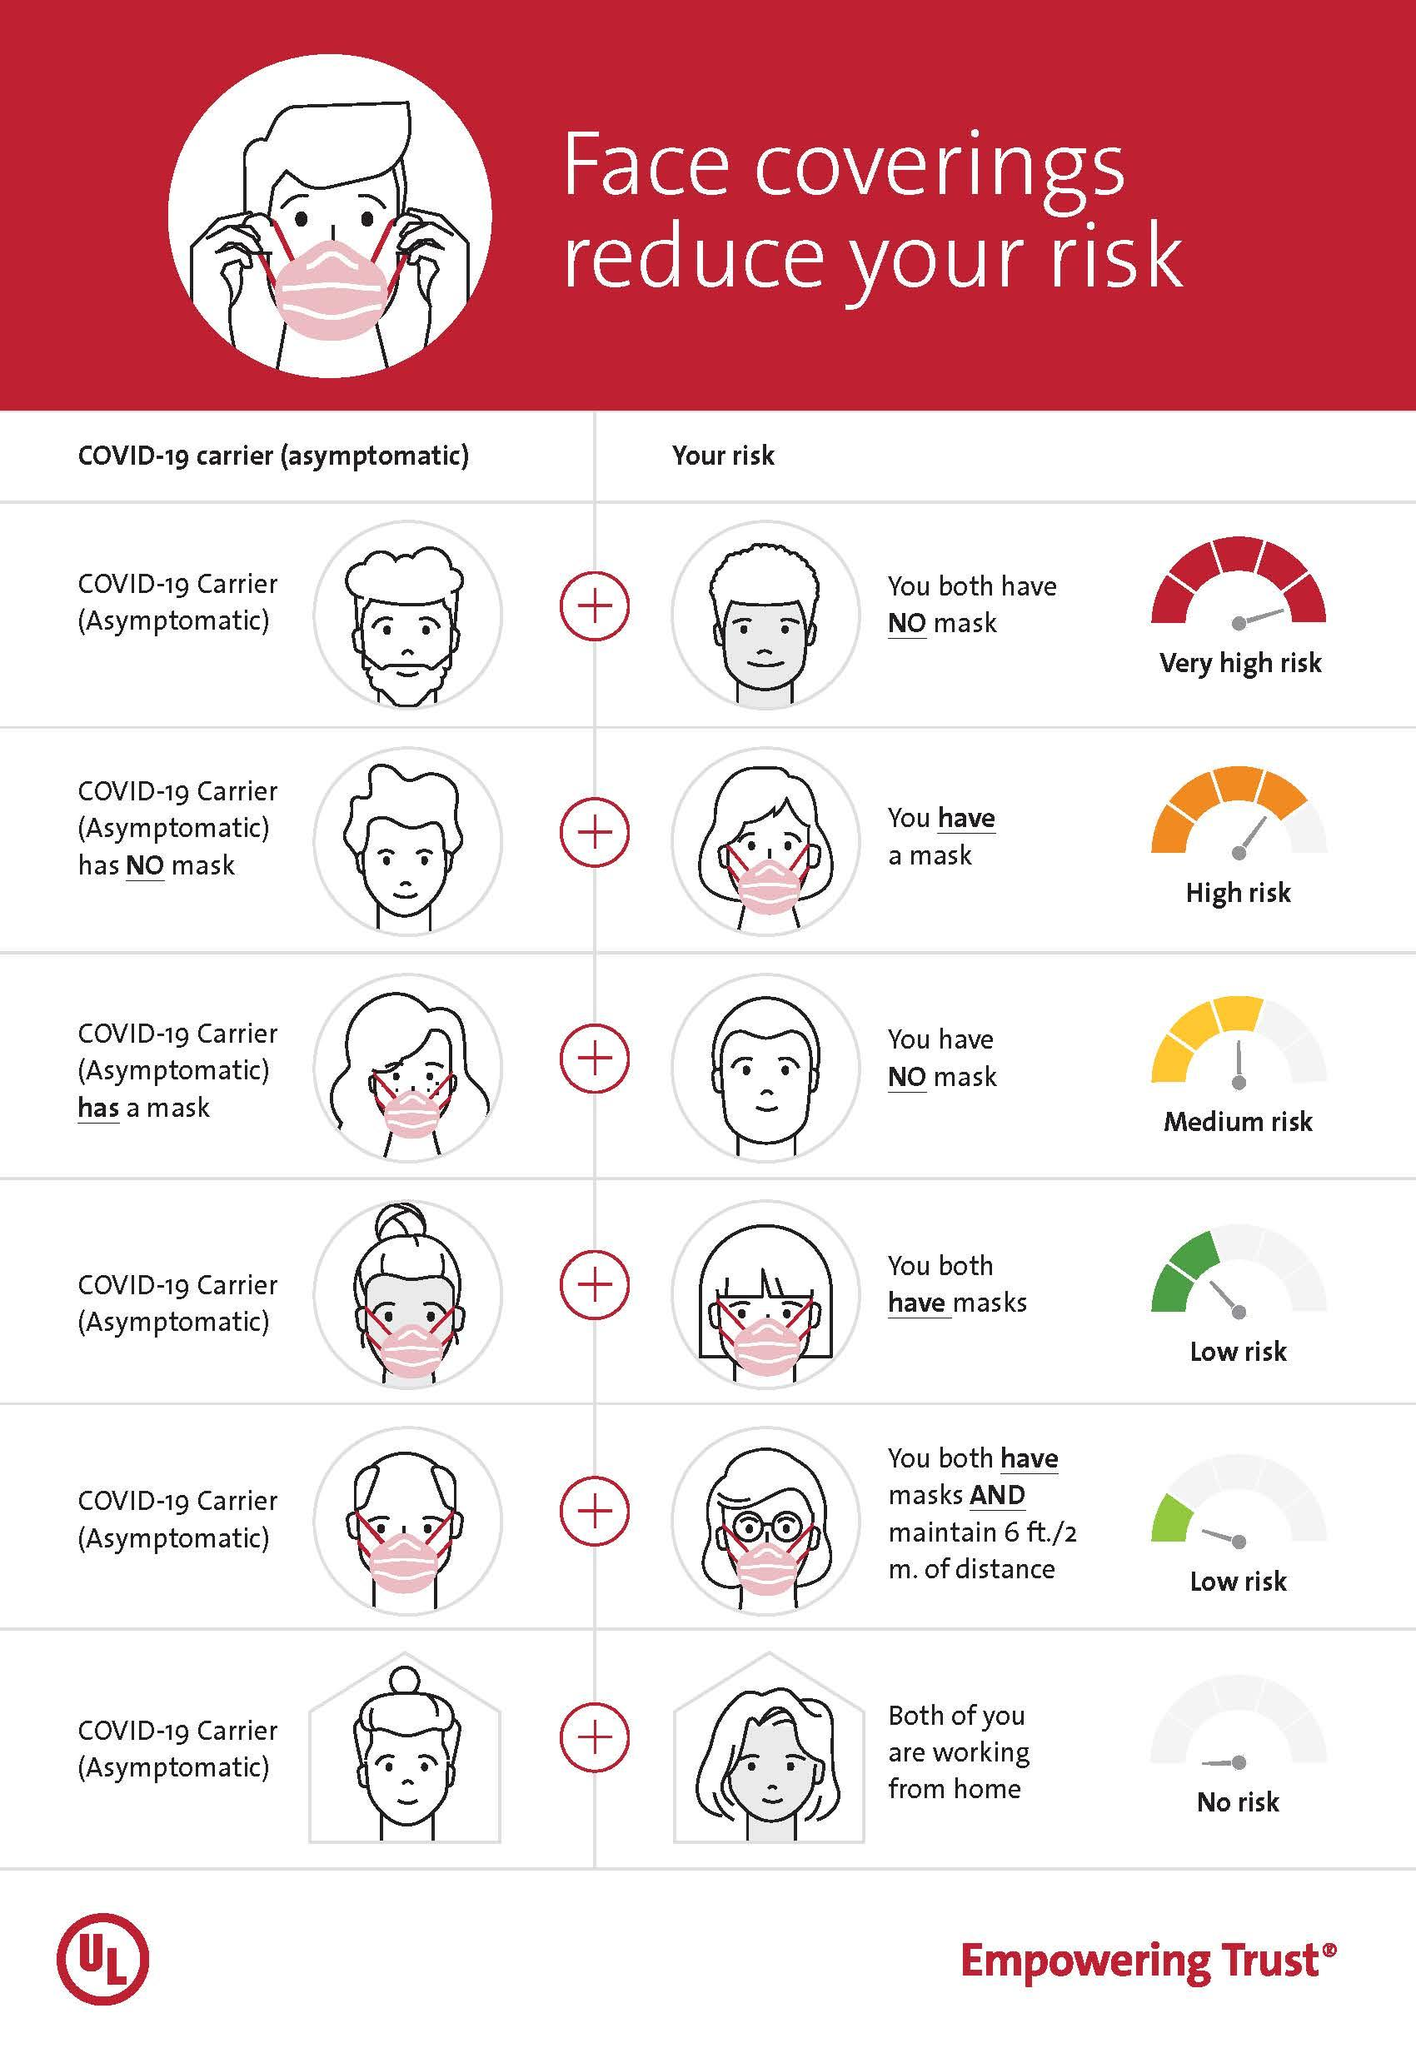Point out several critical features in this image. Six individuals are not wearing masks in this infographic. It is evident from the infographic that a significant number of people, approximately 7, are wearing masks. 